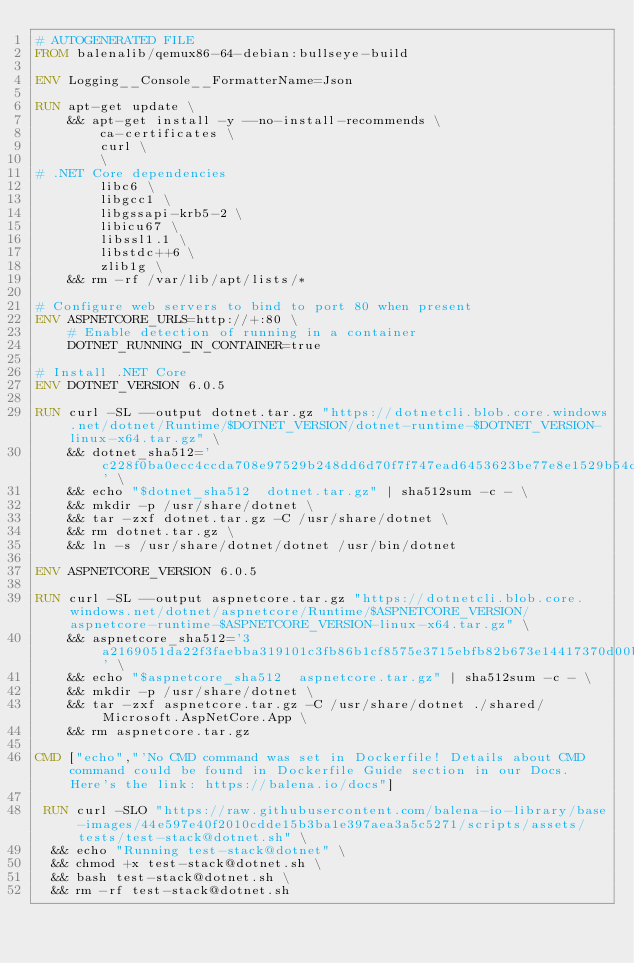Convert code to text. <code><loc_0><loc_0><loc_500><loc_500><_Dockerfile_># AUTOGENERATED FILE
FROM balenalib/qemux86-64-debian:bullseye-build

ENV Logging__Console__FormatterName=Json

RUN apt-get update \
    && apt-get install -y --no-install-recommends \
        ca-certificates \
        curl \
        \
# .NET Core dependencies
        libc6 \
        libgcc1 \
        libgssapi-krb5-2 \
        libicu67 \
        libssl1.1 \
        libstdc++6 \
        zlib1g \
    && rm -rf /var/lib/apt/lists/*

# Configure web servers to bind to port 80 when present
ENV ASPNETCORE_URLS=http://+:80 \
    # Enable detection of running in a container
    DOTNET_RUNNING_IN_CONTAINER=true

# Install .NET Core
ENV DOTNET_VERSION 6.0.5

RUN curl -SL --output dotnet.tar.gz "https://dotnetcli.blob.core.windows.net/dotnet/Runtime/$DOTNET_VERSION/dotnet-runtime-$DOTNET_VERSION-linux-x64.tar.gz" \
    && dotnet_sha512='c228f0ba0ecc4ccda708e97529b248dd6d70f7f747ead6453623be77e8e1529b54db52f5df1b5e00b5b7f92b73389560832f80607fc07e50879d55ce905afcf7' \
    && echo "$dotnet_sha512  dotnet.tar.gz" | sha512sum -c - \
    && mkdir -p /usr/share/dotnet \
    && tar -zxf dotnet.tar.gz -C /usr/share/dotnet \
    && rm dotnet.tar.gz \
    && ln -s /usr/share/dotnet/dotnet /usr/bin/dotnet

ENV ASPNETCORE_VERSION 6.0.5

RUN curl -SL --output aspnetcore.tar.gz "https://dotnetcli.blob.core.windows.net/dotnet/aspnetcore/Runtime/$ASPNETCORE_VERSION/aspnetcore-runtime-$ASPNETCORE_VERSION-linux-x64.tar.gz" \
    && aspnetcore_sha512='3a2169051da22f3faebba319101c3fb86b1cf8575e3715ebfb82b673e14417370d00b958a252c740a6b0e11a8624e4d4ee41fbfd29a4e73af79752dbbeb1477b' \
    && echo "$aspnetcore_sha512  aspnetcore.tar.gz" | sha512sum -c - \
    && mkdir -p /usr/share/dotnet \
    && tar -zxf aspnetcore.tar.gz -C /usr/share/dotnet ./shared/Microsoft.AspNetCore.App \
    && rm aspnetcore.tar.gz

CMD ["echo","'No CMD command was set in Dockerfile! Details about CMD command could be found in Dockerfile Guide section in our Docs. Here's the link: https://balena.io/docs"]

 RUN curl -SLO "https://raw.githubusercontent.com/balena-io-library/base-images/44e597e40f2010cdde15b3ba1e397aea3a5c5271/scripts/assets/tests/test-stack@dotnet.sh" \
  && echo "Running test-stack@dotnet" \
  && chmod +x test-stack@dotnet.sh \
  && bash test-stack@dotnet.sh \
  && rm -rf test-stack@dotnet.sh 
</code> 